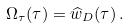<formula> <loc_0><loc_0><loc_500><loc_500>\Omega _ { \tau } ( \tau ) = \widehat { w } _ { D } ( \tau ) \, .</formula> 